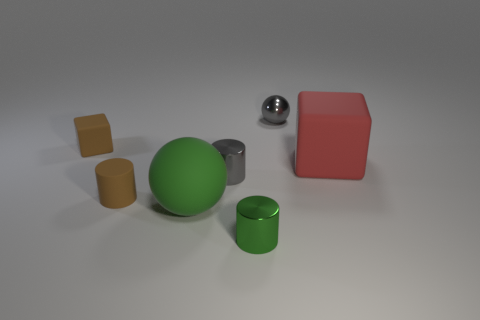Subtract all small metal cylinders. How many cylinders are left? 1 Add 2 small green metal cylinders. How many objects exist? 9 Subtract all spheres. How many objects are left? 5 Subtract all small red rubber cylinders. Subtract all small brown rubber blocks. How many objects are left? 6 Add 2 small green things. How many small green things are left? 3 Add 5 green cylinders. How many green cylinders exist? 6 Subtract 0 gray cubes. How many objects are left? 7 